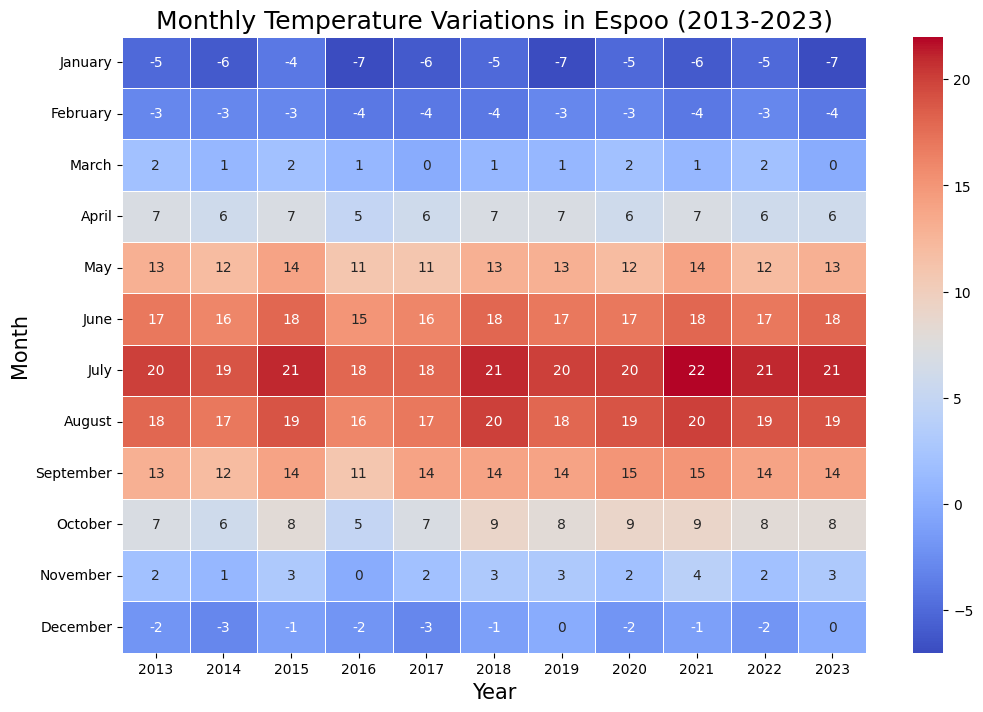When was the warmest July during the past decade? Look for the maximum temperature in the row corresponding to July. The highest value is 22°C in 2021.
Answer: 2021 Which month of 2022 had the lowest temperature? Identify the lowest value in the 2022 column. The minimum temperature is -7°C in January.
Answer: January Is February generally colder or warmer than March? Compare the average temperatures of February and March across different years. On average, February has lower temperatures than March, indicating it is generally colder.
Answer: Colder What is the difference in temperature between December 2019 and December 2023? Check the temperatures for December 2019 (0°C) and December 2023 (0°C). The difference is 0°C.
Answer: 0°C In which year did Espoo experience the warmest May? Find the maximum temperature in the rows corresponding to May. The highest value is 14°C, occurring in 2015, 2021.
Answer: 2015, 2021 Which month shows the most drastic temperature increase from 2020 to 2021? Compare the temperatures for each month between 2020 and 2021. The most significant increase occurs in July, from 20°C in 2020 to 22°C in 2021.
Answer: July How many times did the temperature in January drop below -6°C? Count the instances of temperatures below -6°C in the January row. It occurred 4 times: 2016, 2017, 2019, 2023.
Answer: 4 times Which month and year combination had the overall highest temperature on the heatmap? Identify the single highest temperature value in the entire heatmap. The maximum temperature is 22°C, observed in July 2021.
Answer: July 2021 Does the month of October show a temperature trend over the decade? By examining the temperature values in October over the years, there's a slight trend of increase, ranging from 6°C in 2014 to 9°C in 2021, 2020, and 2018.
Answer: Trend of slight increase What is the average temperature in March over the decade? Sum the temperatures in the March row across all years and divide by the number of years. Average = (2 + 1 + 2 + 1 + 0 + 1 + 0 + 1 + 1 + 0) / 11 = 1.
Answer: 1°C 